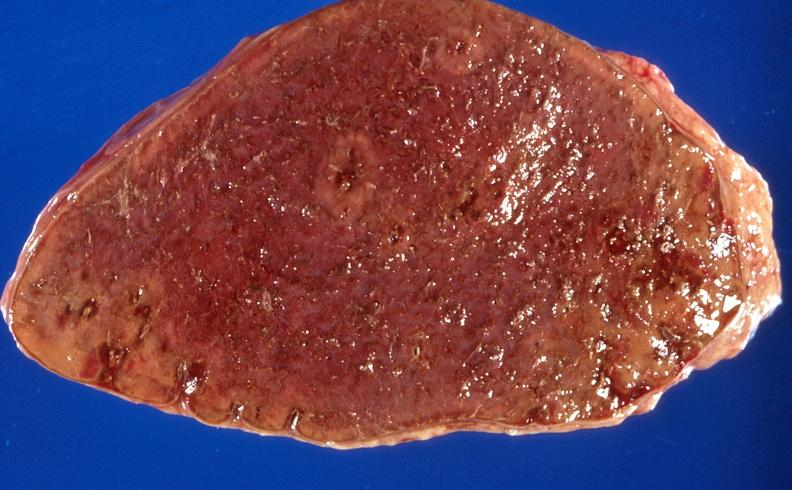where is this part in?
Answer the question using a single word or phrase. Spleen 